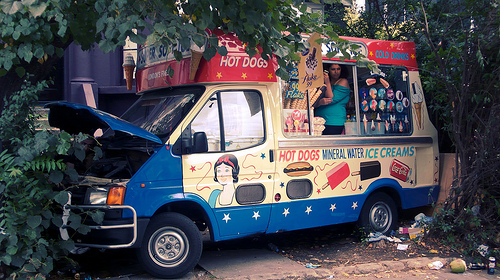<image>
Can you confirm if the lolly is in the wheel? No. The lolly is not contained within the wheel. These objects have a different spatial relationship. Is the ice cream in front of the hot dog? No. The ice cream is not in front of the hot dog. The spatial positioning shows a different relationship between these objects. 